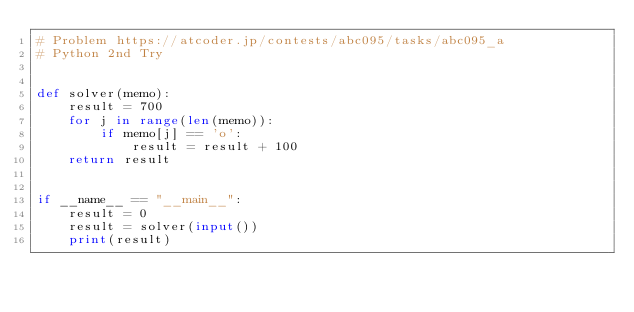<code> <loc_0><loc_0><loc_500><loc_500><_Python_># Problem https://atcoder.jp/contests/abc095/tasks/abc095_a
# Python 2nd Try


def solver(memo):
    result = 700
    for j in range(len(memo)):
        if memo[j] == 'o':
            result = result + 100
    return result


if __name__ == "__main__":
    result = 0
    result = solver(input())
    print(result)
</code> 